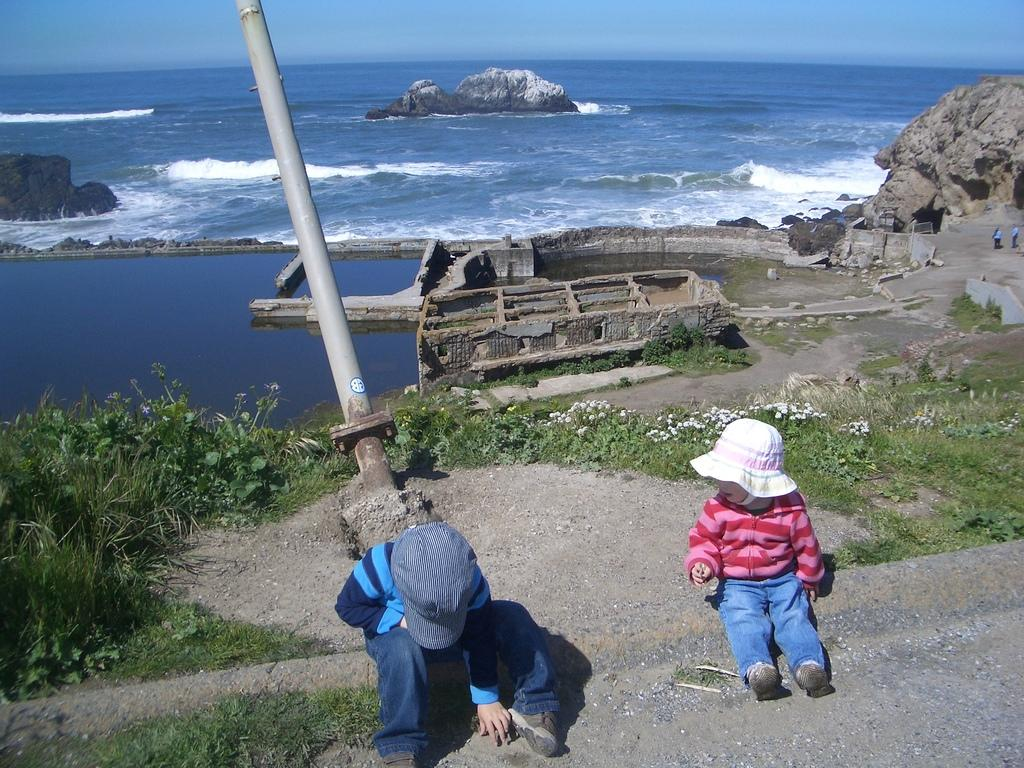How many people are present in the image? There are two people sitting in the image. What can be seen in the background of the image? There are green plants, a pole, rocks, and water visible in the background. What is the color of the sky in the image? The sky is blue in color. What type of lumber is being used by the people in the image? There is no lumber present in the image; it features two people sitting and the background elements mentioned earlier. What hobbies do the people in the image enjoy? The provided facts do not give any information about the hobbies of the people in the image. 